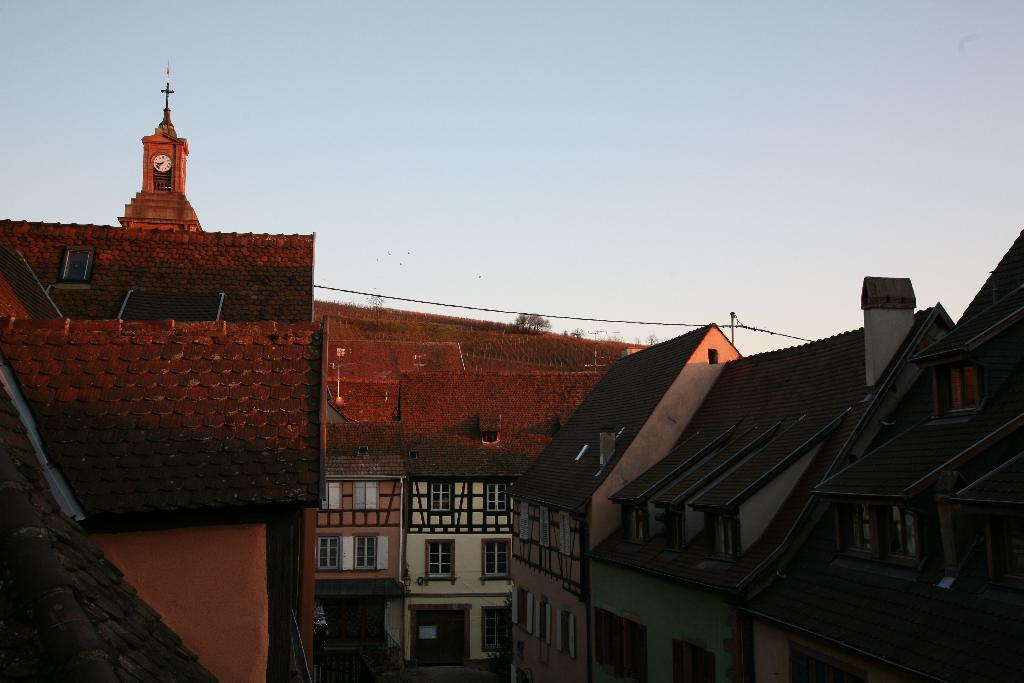What type of structures can be seen in the image? There are buildings in the image. Can you describe any specific details about the buildings? Unfortunately, the provided facts do not mention any specific details about the buildings. Is there any other object or feature visible in the image besides the buildings? Yes, there is a clock in the top left corner of the image. How many yaks are visible in the image? There are no yaks present in the image. What type of copy machine is being used in the image? There is no copy machine present in the image. 